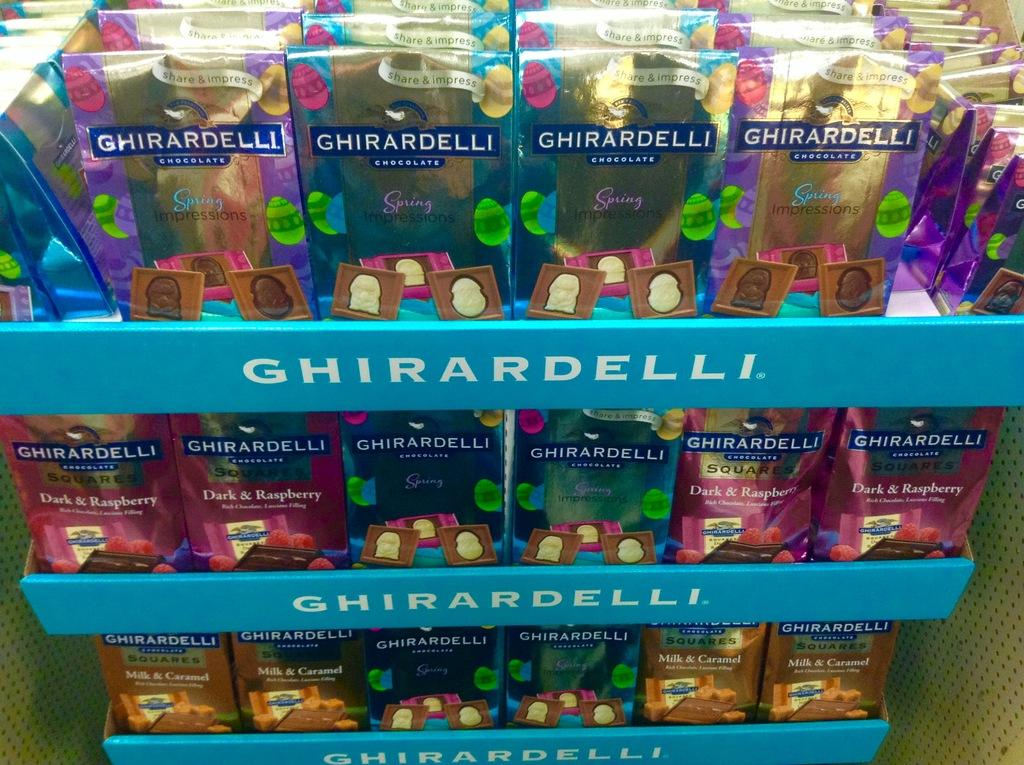<image>
Create a compact narrative representing the image presented. A display stand for Ghirardelli boxes of a variety of colors 